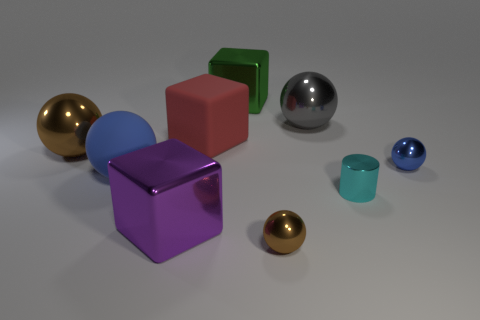Subtract all gray spheres. How many spheres are left? 4 Subtract 2 spheres. How many spheres are left? 3 Subtract all large brown spheres. How many spheres are left? 4 Subtract all green spheres. Subtract all gray blocks. How many spheres are left? 5 Add 1 gray objects. How many objects exist? 10 Subtract all cylinders. How many objects are left? 8 Add 1 blue metal cubes. How many blue metal cubes exist? 1 Subtract 1 green cubes. How many objects are left? 8 Subtract all big brown shiny balls. Subtract all large blocks. How many objects are left? 5 Add 2 purple objects. How many purple objects are left? 3 